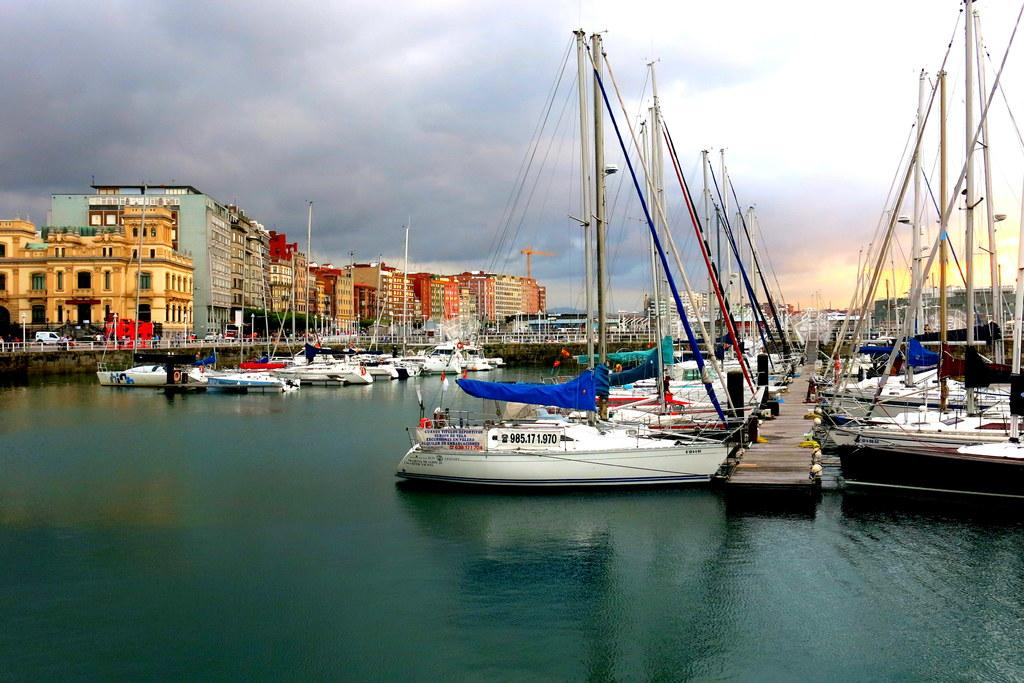What is on the water in the image? There are boats on the water in the image. What structure can be seen crossing over the water? There is a bridge in the image. What type of man-made structures are present in the image? There are buildings in the image. What type of vegetation is present in the image? There are trees in the image. What can be seen in the background of the image? The sky is visible in the background of the image. What type of lace is being used to decorate the grandmother's art in the image? There is no grandmother, art, or lace present in the image. 